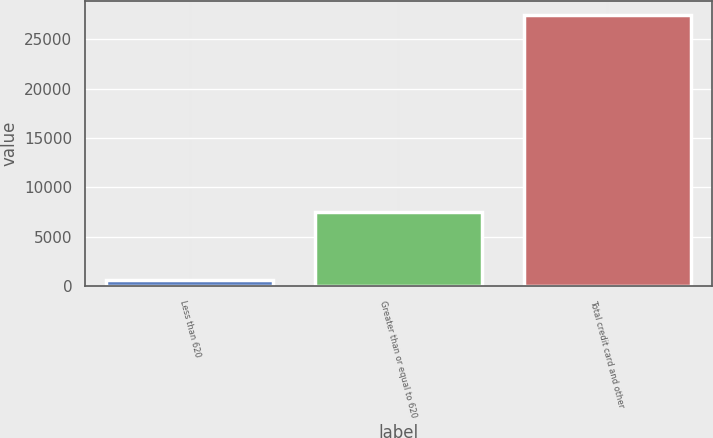Convert chart. <chart><loc_0><loc_0><loc_500><loc_500><bar_chart><fcel>Less than 620<fcel>Greater than or equal to 620<fcel>Total credit card and other<nl><fcel>631<fcel>7528<fcel>27465<nl></chart> 